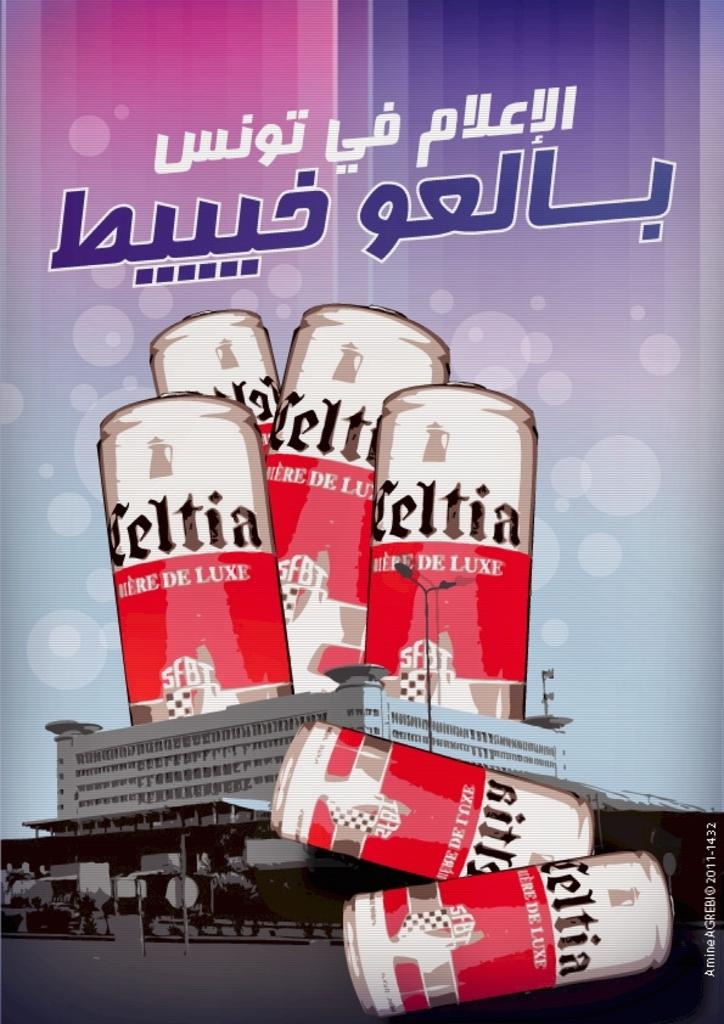<image>
Describe the image concisely. A couple of the Celtia cans have fallen off of the roof in this advertisement. 